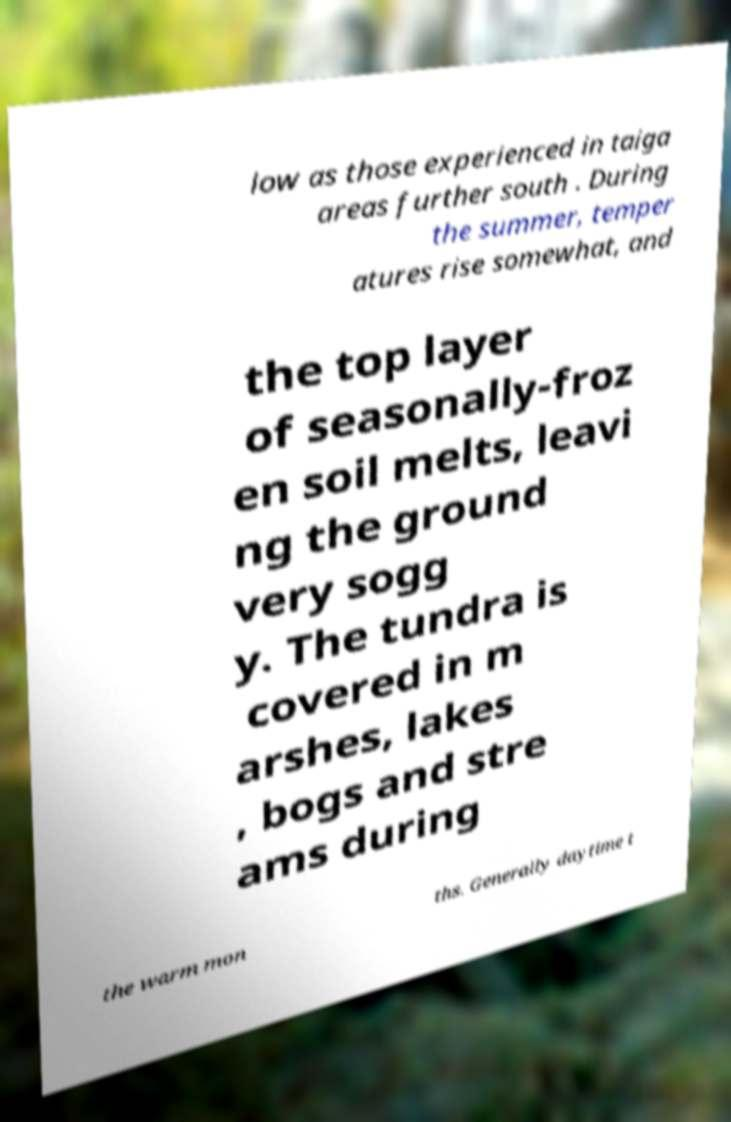Please identify and transcribe the text found in this image. low as those experienced in taiga areas further south . During the summer, temper atures rise somewhat, and the top layer of seasonally-froz en soil melts, leavi ng the ground very sogg y. The tundra is covered in m arshes, lakes , bogs and stre ams during the warm mon ths. Generally daytime t 